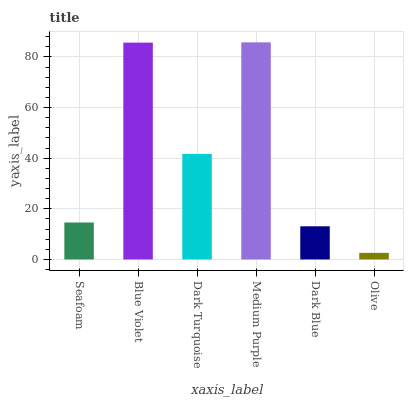Is Olive the minimum?
Answer yes or no. Yes. Is Medium Purple the maximum?
Answer yes or no. Yes. Is Blue Violet the minimum?
Answer yes or no. No. Is Blue Violet the maximum?
Answer yes or no. No. Is Blue Violet greater than Seafoam?
Answer yes or no. Yes. Is Seafoam less than Blue Violet?
Answer yes or no. Yes. Is Seafoam greater than Blue Violet?
Answer yes or no. No. Is Blue Violet less than Seafoam?
Answer yes or no. No. Is Dark Turquoise the high median?
Answer yes or no. Yes. Is Seafoam the low median?
Answer yes or no. Yes. Is Olive the high median?
Answer yes or no. No. Is Dark Blue the low median?
Answer yes or no. No. 